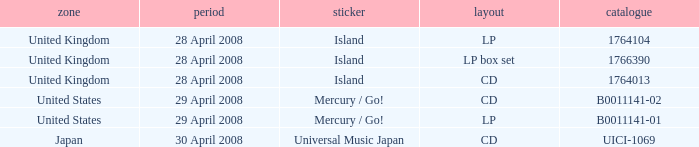What is the Label of the UICI-1069 Catalog? Universal Music Japan. 